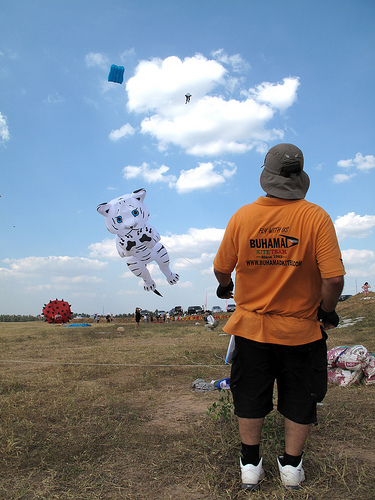<image>
Can you confirm if the kite is above the person? Yes. The kite is positioned above the person in the vertical space, higher up in the scene. 